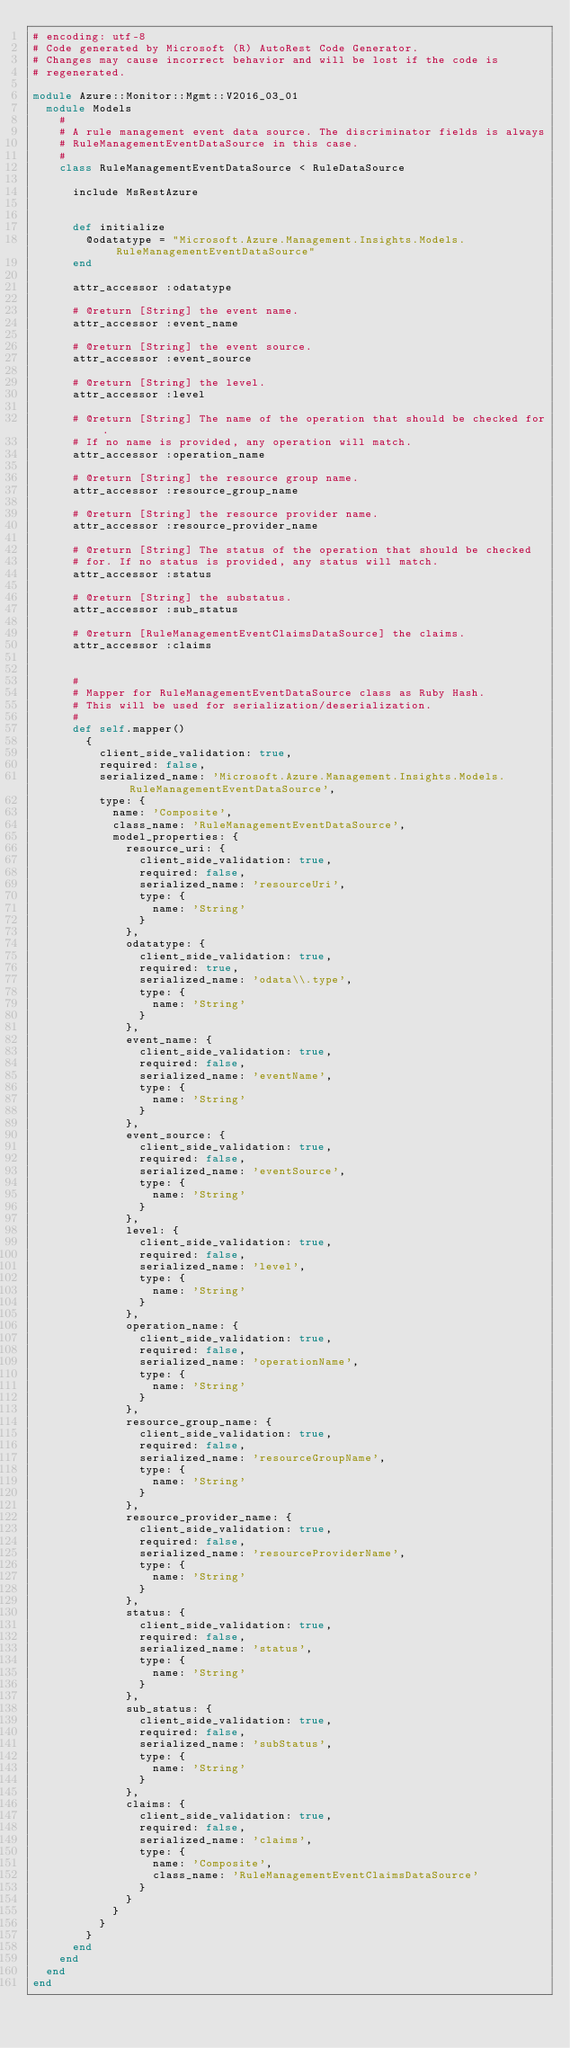<code> <loc_0><loc_0><loc_500><loc_500><_Ruby_># encoding: utf-8
# Code generated by Microsoft (R) AutoRest Code Generator.
# Changes may cause incorrect behavior and will be lost if the code is
# regenerated.

module Azure::Monitor::Mgmt::V2016_03_01
  module Models
    #
    # A rule management event data source. The discriminator fields is always
    # RuleManagementEventDataSource in this case.
    #
    class RuleManagementEventDataSource < RuleDataSource

      include MsRestAzure


      def initialize
        @odatatype = "Microsoft.Azure.Management.Insights.Models.RuleManagementEventDataSource"
      end

      attr_accessor :odatatype

      # @return [String] the event name.
      attr_accessor :event_name

      # @return [String] the event source.
      attr_accessor :event_source

      # @return [String] the level.
      attr_accessor :level

      # @return [String] The name of the operation that should be checked for.
      # If no name is provided, any operation will match.
      attr_accessor :operation_name

      # @return [String] the resource group name.
      attr_accessor :resource_group_name

      # @return [String] the resource provider name.
      attr_accessor :resource_provider_name

      # @return [String] The status of the operation that should be checked
      # for. If no status is provided, any status will match.
      attr_accessor :status

      # @return [String] the substatus.
      attr_accessor :sub_status

      # @return [RuleManagementEventClaimsDataSource] the claims.
      attr_accessor :claims


      #
      # Mapper for RuleManagementEventDataSource class as Ruby Hash.
      # This will be used for serialization/deserialization.
      #
      def self.mapper()
        {
          client_side_validation: true,
          required: false,
          serialized_name: 'Microsoft.Azure.Management.Insights.Models.RuleManagementEventDataSource',
          type: {
            name: 'Composite',
            class_name: 'RuleManagementEventDataSource',
            model_properties: {
              resource_uri: {
                client_side_validation: true,
                required: false,
                serialized_name: 'resourceUri',
                type: {
                  name: 'String'
                }
              },
              odatatype: {
                client_side_validation: true,
                required: true,
                serialized_name: 'odata\\.type',
                type: {
                  name: 'String'
                }
              },
              event_name: {
                client_side_validation: true,
                required: false,
                serialized_name: 'eventName',
                type: {
                  name: 'String'
                }
              },
              event_source: {
                client_side_validation: true,
                required: false,
                serialized_name: 'eventSource',
                type: {
                  name: 'String'
                }
              },
              level: {
                client_side_validation: true,
                required: false,
                serialized_name: 'level',
                type: {
                  name: 'String'
                }
              },
              operation_name: {
                client_side_validation: true,
                required: false,
                serialized_name: 'operationName',
                type: {
                  name: 'String'
                }
              },
              resource_group_name: {
                client_side_validation: true,
                required: false,
                serialized_name: 'resourceGroupName',
                type: {
                  name: 'String'
                }
              },
              resource_provider_name: {
                client_side_validation: true,
                required: false,
                serialized_name: 'resourceProviderName',
                type: {
                  name: 'String'
                }
              },
              status: {
                client_side_validation: true,
                required: false,
                serialized_name: 'status',
                type: {
                  name: 'String'
                }
              },
              sub_status: {
                client_side_validation: true,
                required: false,
                serialized_name: 'subStatus',
                type: {
                  name: 'String'
                }
              },
              claims: {
                client_side_validation: true,
                required: false,
                serialized_name: 'claims',
                type: {
                  name: 'Composite',
                  class_name: 'RuleManagementEventClaimsDataSource'
                }
              }
            }
          }
        }
      end
    end
  end
end
</code> 